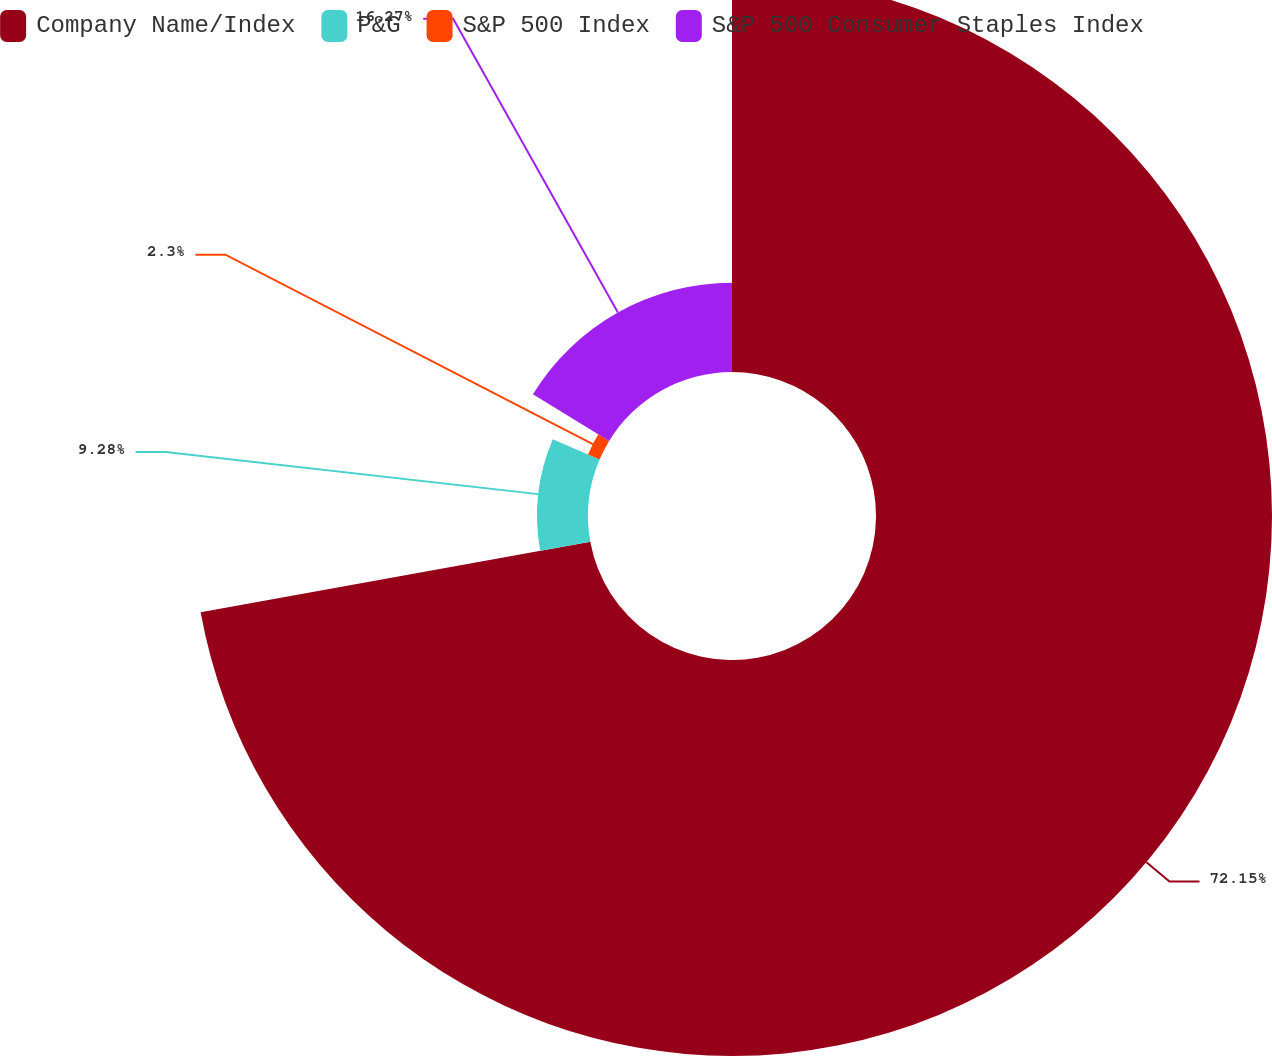<chart> <loc_0><loc_0><loc_500><loc_500><pie_chart><fcel>Company Name/Index<fcel>P&G<fcel>S&P 500 Index<fcel>S&P 500 Consumer Staples Index<nl><fcel>72.15%<fcel>9.28%<fcel>2.3%<fcel>16.27%<nl></chart> 